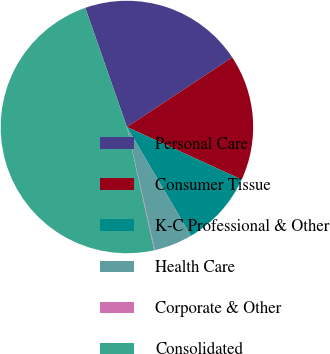<chart> <loc_0><loc_0><loc_500><loc_500><pie_chart><fcel>Personal Care<fcel>Consumer Tissue<fcel>K-C Professional & Other<fcel>Health Care<fcel>Corporate & Other<fcel>Consolidated<nl><fcel>21.06%<fcel>16.13%<fcel>9.7%<fcel>4.9%<fcel>0.09%<fcel>48.12%<nl></chart> 